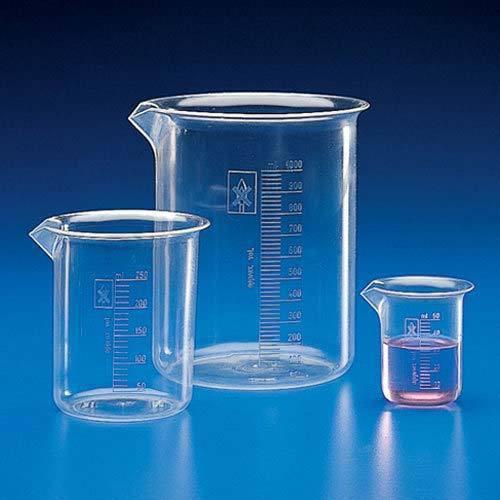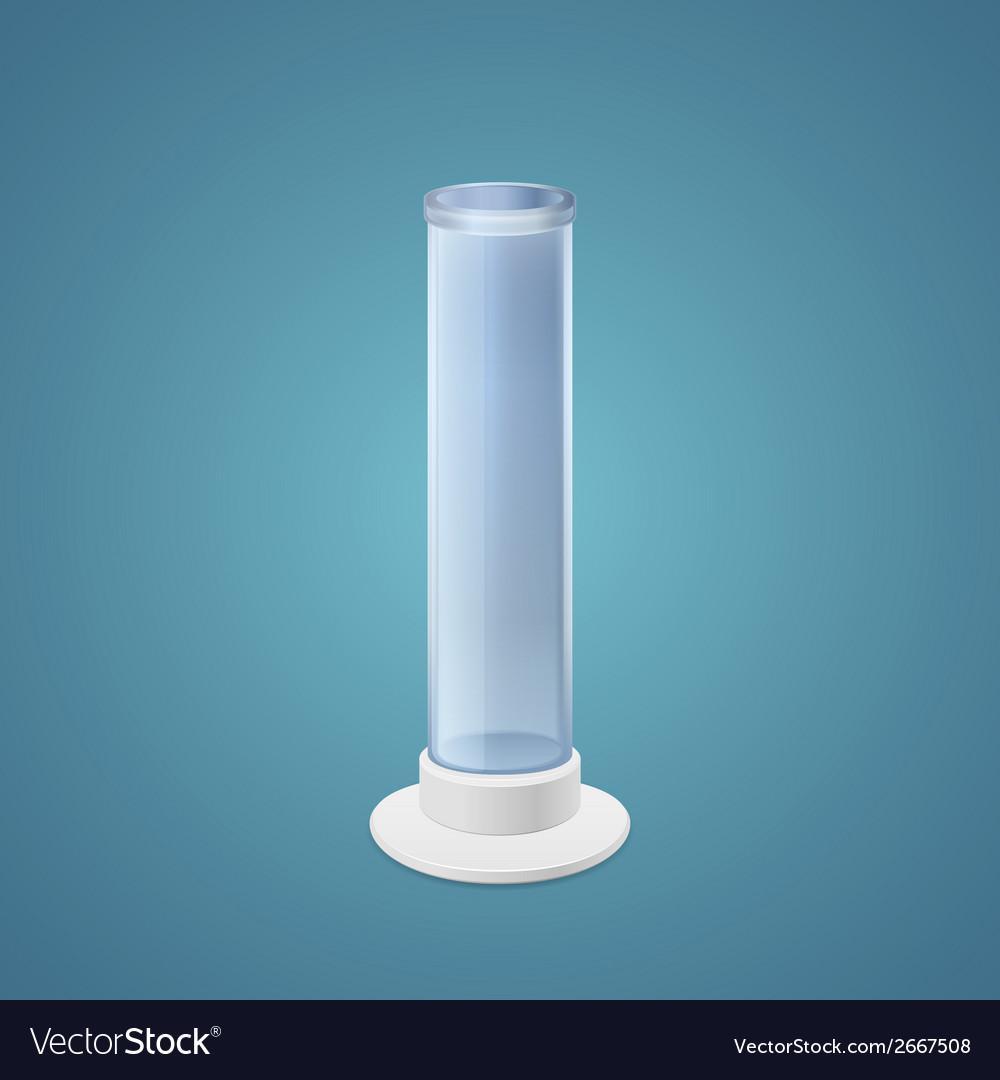The first image is the image on the left, the second image is the image on the right. Considering the images on both sides, is "Each image includes at least one slender test tube-shaped cylinder that stands on a flat hexagon-shaped base." valid? Answer yes or no. No. The first image is the image on the left, the second image is the image on the right. Assess this claim about the two images: "There is one cylinder and three beakers.". Correct or not? Answer yes or no. Yes. 